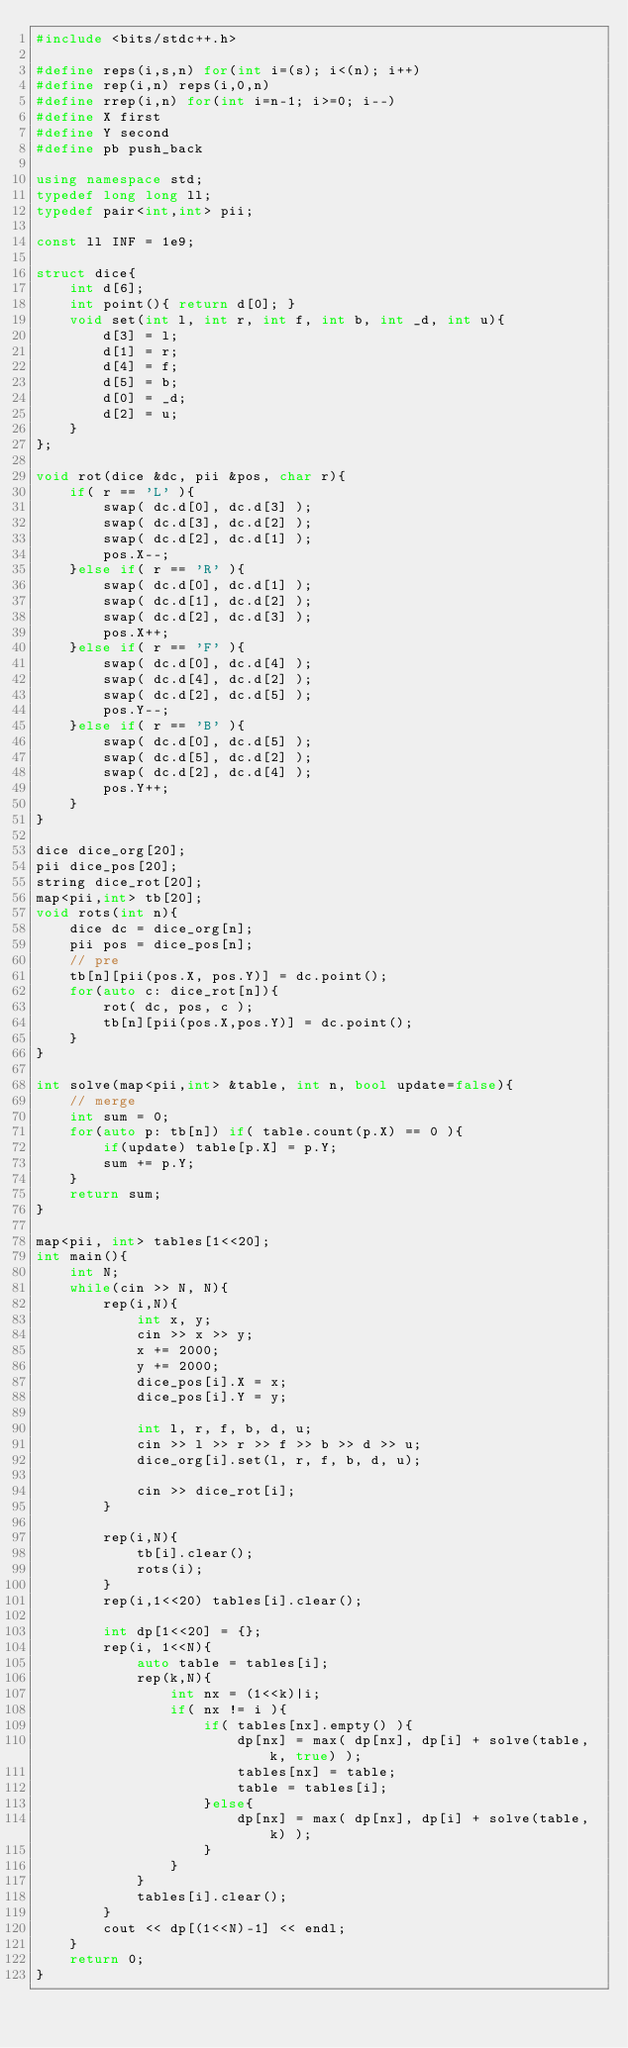<code> <loc_0><loc_0><loc_500><loc_500><_C++_>#include <bits/stdc++.h>

#define reps(i,s,n) for(int i=(s); i<(n); i++)
#define rep(i,n) reps(i,0,n)
#define rrep(i,n) for(int i=n-1; i>=0; i--)
#define X first
#define Y second
#define pb push_back

using namespace std;
typedef long long ll;
typedef pair<int,int> pii;

const ll INF = 1e9;

struct dice{
	int d[6];
	int point(){ return d[0]; }
	void set(int l, int r, int f, int b, int _d, int u){
		d[3] = l;
		d[1] = r;
		d[4] = f;
		d[5] = b;
		d[0] = _d;
		d[2] = u;
	}
};

void rot(dice &dc, pii &pos, char r){
	if( r == 'L' ){
		swap( dc.d[0], dc.d[3] );
		swap( dc.d[3], dc.d[2] );
		swap( dc.d[2], dc.d[1] );
		pos.X--;
	}else if( r == 'R' ){
		swap( dc.d[0], dc.d[1] );
		swap( dc.d[1], dc.d[2] );
		swap( dc.d[2], dc.d[3] );
		pos.X++;
	}else if( r == 'F' ){
		swap( dc.d[0], dc.d[4] );
		swap( dc.d[4], dc.d[2] );
		swap( dc.d[2], dc.d[5] );
		pos.Y--;
	}else if( r == 'B' ){
		swap( dc.d[0], dc.d[5] );
		swap( dc.d[5], dc.d[2] );
		swap( dc.d[2], dc.d[4] );
		pos.Y++;
	}
}

dice dice_org[20];
pii dice_pos[20];
string dice_rot[20];
map<pii,int> tb[20];
void rots(int n){
	dice dc = dice_org[n];
	pii pos = dice_pos[n];
	// pre
	tb[n][pii(pos.X, pos.Y)] = dc.point();
	for(auto c: dice_rot[n]){
		rot( dc, pos, c );
		tb[n][pii(pos.X,pos.Y)] = dc.point();
	}
}

int solve(map<pii,int> &table, int n, bool update=false){
	// merge
	int sum = 0;
	for(auto p: tb[n]) if( table.count(p.X) == 0 ){
		if(update) table[p.X] = p.Y;
		sum += p.Y;
	}
	return sum;
}

map<pii, int> tables[1<<20];
int main(){
	int N;
	while(cin >> N, N){
		rep(i,N){
			int x, y;
			cin >> x >> y;
			x += 2000;
			y += 2000;
			dice_pos[i].X = x;
			dice_pos[i].Y = y;

			int l, r, f, b, d, u; 
			cin >> l >> r >> f >> b >> d >> u; 
			dice_org[i].set(l, r, f, b, d, u);

			cin >> dice_rot[i];
		}

		rep(i,N){
			tb[i].clear();
			rots(i);
		}
		rep(i,1<<20) tables[i].clear();

		int dp[1<<20] = {};
		rep(i, 1<<N){
			auto table = tables[i];
			rep(k,N){
				int nx = (1<<k)|i;
				if( nx != i ){
					if( tables[nx].empty() ){
						dp[nx] = max( dp[nx], dp[i] + solve(table, k, true) );
						tables[nx] = table;
						table = tables[i];
					}else{
						dp[nx] = max( dp[nx], dp[i] + solve(table, k) );
					}
				}
			}
			tables[i].clear();
		}
		cout << dp[(1<<N)-1] << endl;
	}
	return 0;
}</code> 